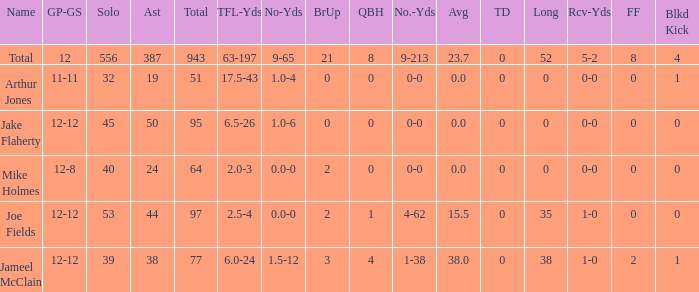What is the largest number of tds scored for a player? 0.0. 